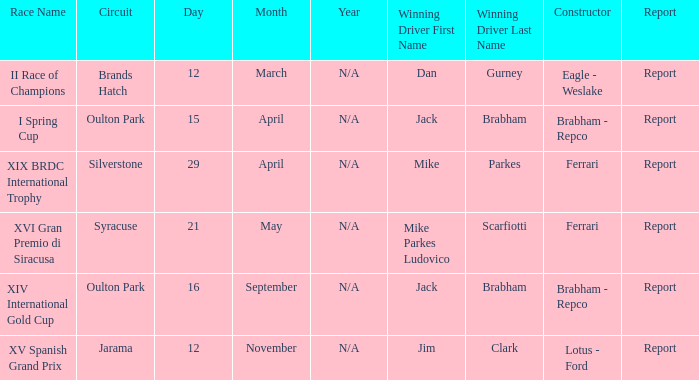What is the circuit held on 15 april? Oulton Park. 